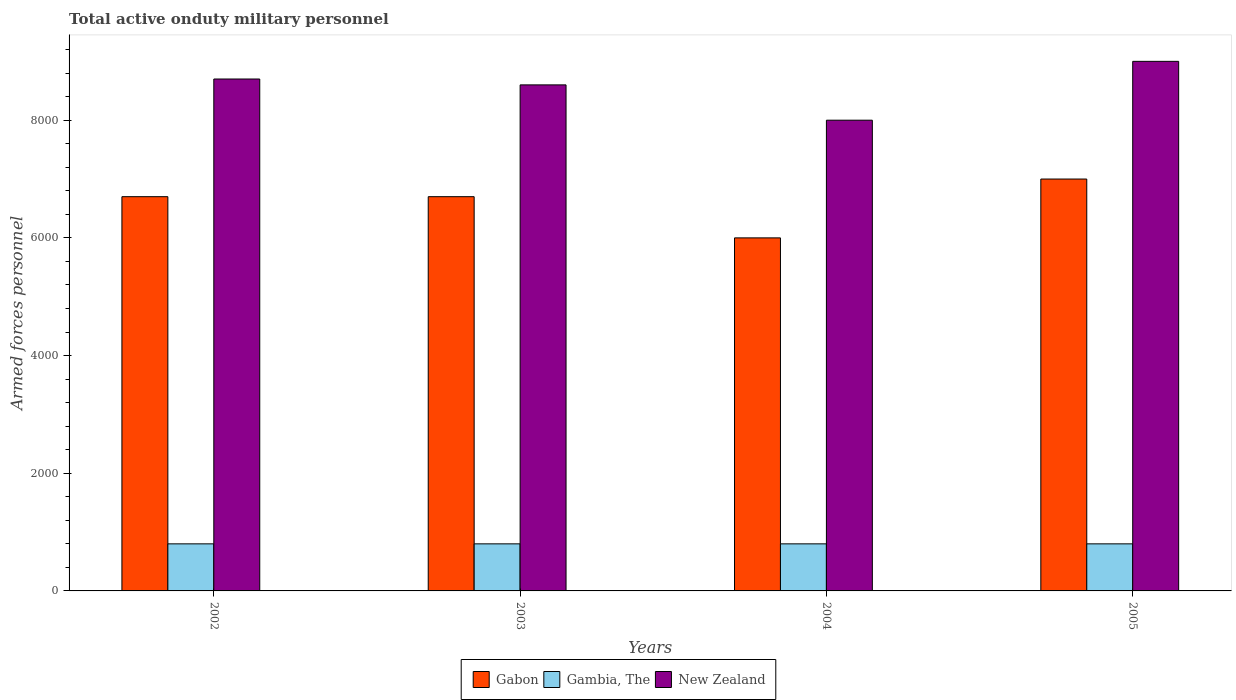How many different coloured bars are there?
Give a very brief answer. 3. How many groups of bars are there?
Provide a succinct answer. 4. Are the number of bars per tick equal to the number of legend labels?
Give a very brief answer. Yes. Are the number of bars on each tick of the X-axis equal?
Offer a very short reply. Yes. How many bars are there on the 2nd tick from the left?
Ensure brevity in your answer.  3. What is the label of the 4th group of bars from the left?
Make the answer very short. 2005. What is the number of armed forces personnel in New Zealand in 2003?
Provide a succinct answer. 8600. Across all years, what is the maximum number of armed forces personnel in Gabon?
Keep it short and to the point. 7000. Across all years, what is the minimum number of armed forces personnel in Gambia, The?
Your response must be concise. 800. In which year was the number of armed forces personnel in Gambia, The maximum?
Offer a terse response. 2002. What is the total number of armed forces personnel in New Zealand in the graph?
Give a very brief answer. 3.43e+04. What is the difference between the number of armed forces personnel in Gambia, The in 2003 and that in 2004?
Your response must be concise. 0. What is the difference between the number of armed forces personnel in New Zealand in 2003 and the number of armed forces personnel in Gambia, The in 2002?
Offer a very short reply. 7800. What is the average number of armed forces personnel in New Zealand per year?
Give a very brief answer. 8575. In the year 2004, what is the difference between the number of armed forces personnel in Gambia, The and number of armed forces personnel in New Zealand?
Provide a succinct answer. -7200. In how many years, is the number of armed forces personnel in Gabon greater than 4800?
Keep it short and to the point. 4. What is the ratio of the number of armed forces personnel in Gabon in 2002 to that in 2004?
Give a very brief answer. 1.12. What is the difference between the highest and the second highest number of armed forces personnel in New Zealand?
Provide a succinct answer. 300. What is the difference between the highest and the lowest number of armed forces personnel in Gambia, The?
Give a very brief answer. 0. In how many years, is the number of armed forces personnel in Gabon greater than the average number of armed forces personnel in Gabon taken over all years?
Your response must be concise. 3. What does the 3rd bar from the left in 2005 represents?
Offer a very short reply. New Zealand. What does the 3rd bar from the right in 2005 represents?
Provide a succinct answer. Gabon. Is it the case that in every year, the sum of the number of armed forces personnel in Gambia, The and number of armed forces personnel in Gabon is greater than the number of armed forces personnel in New Zealand?
Offer a terse response. No. Are all the bars in the graph horizontal?
Give a very brief answer. No. Are the values on the major ticks of Y-axis written in scientific E-notation?
Offer a very short reply. No. How are the legend labels stacked?
Your answer should be very brief. Horizontal. What is the title of the graph?
Give a very brief answer. Total active onduty military personnel. Does "Malaysia" appear as one of the legend labels in the graph?
Offer a terse response. No. What is the label or title of the Y-axis?
Your answer should be compact. Armed forces personnel. What is the Armed forces personnel of Gabon in 2002?
Make the answer very short. 6700. What is the Armed forces personnel of Gambia, The in 2002?
Offer a terse response. 800. What is the Armed forces personnel in New Zealand in 2002?
Your answer should be compact. 8700. What is the Armed forces personnel in Gabon in 2003?
Your response must be concise. 6700. What is the Armed forces personnel in Gambia, The in 2003?
Offer a very short reply. 800. What is the Armed forces personnel in New Zealand in 2003?
Give a very brief answer. 8600. What is the Armed forces personnel in Gabon in 2004?
Your answer should be very brief. 6000. What is the Armed forces personnel in Gambia, The in 2004?
Give a very brief answer. 800. What is the Armed forces personnel of New Zealand in 2004?
Your response must be concise. 8000. What is the Armed forces personnel of Gabon in 2005?
Offer a terse response. 7000. What is the Armed forces personnel in Gambia, The in 2005?
Ensure brevity in your answer.  800. What is the Armed forces personnel in New Zealand in 2005?
Provide a short and direct response. 9000. Across all years, what is the maximum Armed forces personnel of Gabon?
Offer a very short reply. 7000. Across all years, what is the maximum Armed forces personnel of Gambia, The?
Give a very brief answer. 800. Across all years, what is the maximum Armed forces personnel in New Zealand?
Your answer should be very brief. 9000. Across all years, what is the minimum Armed forces personnel of Gabon?
Your answer should be very brief. 6000. Across all years, what is the minimum Armed forces personnel of Gambia, The?
Offer a terse response. 800. Across all years, what is the minimum Armed forces personnel in New Zealand?
Your response must be concise. 8000. What is the total Armed forces personnel in Gabon in the graph?
Your answer should be compact. 2.64e+04. What is the total Armed forces personnel in Gambia, The in the graph?
Provide a short and direct response. 3200. What is the total Armed forces personnel in New Zealand in the graph?
Provide a short and direct response. 3.43e+04. What is the difference between the Armed forces personnel of Gabon in 2002 and that in 2003?
Your answer should be compact. 0. What is the difference between the Armed forces personnel in Gabon in 2002 and that in 2004?
Offer a very short reply. 700. What is the difference between the Armed forces personnel of New Zealand in 2002 and that in 2004?
Keep it short and to the point. 700. What is the difference between the Armed forces personnel in Gabon in 2002 and that in 2005?
Make the answer very short. -300. What is the difference between the Armed forces personnel in Gambia, The in 2002 and that in 2005?
Your answer should be compact. 0. What is the difference between the Armed forces personnel of New Zealand in 2002 and that in 2005?
Provide a succinct answer. -300. What is the difference between the Armed forces personnel in Gabon in 2003 and that in 2004?
Your response must be concise. 700. What is the difference between the Armed forces personnel in Gambia, The in 2003 and that in 2004?
Your answer should be very brief. 0. What is the difference between the Armed forces personnel in New Zealand in 2003 and that in 2004?
Offer a very short reply. 600. What is the difference between the Armed forces personnel of Gabon in 2003 and that in 2005?
Ensure brevity in your answer.  -300. What is the difference between the Armed forces personnel in Gambia, The in 2003 and that in 2005?
Provide a succinct answer. 0. What is the difference between the Armed forces personnel in New Zealand in 2003 and that in 2005?
Offer a terse response. -400. What is the difference between the Armed forces personnel in Gabon in 2004 and that in 2005?
Offer a terse response. -1000. What is the difference between the Armed forces personnel in Gambia, The in 2004 and that in 2005?
Your answer should be compact. 0. What is the difference between the Armed forces personnel of New Zealand in 2004 and that in 2005?
Your response must be concise. -1000. What is the difference between the Armed forces personnel in Gabon in 2002 and the Armed forces personnel in Gambia, The in 2003?
Your response must be concise. 5900. What is the difference between the Armed forces personnel in Gabon in 2002 and the Armed forces personnel in New Zealand in 2003?
Your answer should be compact. -1900. What is the difference between the Armed forces personnel of Gambia, The in 2002 and the Armed forces personnel of New Zealand in 2003?
Your response must be concise. -7800. What is the difference between the Armed forces personnel of Gabon in 2002 and the Armed forces personnel of Gambia, The in 2004?
Make the answer very short. 5900. What is the difference between the Armed forces personnel in Gabon in 2002 and the Armed forces personnel in New Zealand in 2004?
Give a very brief answer. -1300. What is the difference between the Armed forces personnel of Gambia, The in 2002 and the Armed forces personnel of New Zealand in 2004?
Provide a succinct answer. -7200. What is the difference between the Armed forces personnel of Gabon in 2002 and the Armed forces personnel of Gambia, The in 2005?
Provide a short and direct response. 5900. What is the difference between the Armed forces personnel in Gabon in 2002 and the Armed forces personnel in New Zealand in 2005?
Your answer should be very brief. -2300. What is the difference between the Armed forces personnel in Gambia, The in 2002 and the Armed forces personnel in New Zealand in 2005?
Your answer should be compact. -8200. What is the difference between the Armed forces personnel in Gabon in 2003 and the Armed forces personnel in Gambia, The in 2004?
Your response must be concise. 5900. What is the difference between the Armed forces personnel in Gabon in 2003 and the Armed forces personnel in New Zealand in 2004?
Your answer should be compact. -1300. What is the difference between the Armed forces personnel in Gambia, The in 2003 and the Armed forces personnel in New Zealand in 2004?
Your answer should be compact. -7200. What is the difference between the Armed forces personnel in Gabon in 2003 and the Armed forces personnel in Gambia, The in 2005?
Provide a short and direct response. 5900. What is the difference between the Armed forces personnel of Gabon in 2003 and the Armed forces personnel of New Zealand in 2005?
Provide a succinct answer. -2300. What is the difference between the Armed forces personnel in Gambia, The in 2003 and the Armed forces personnel in New Zealand in 2005?
Your answer should be very brief. -8200. What is the difference between the Armed forces personnel in Gabon in 2004 and the Armed forces personnel in Gambia, The in 2005?
Give a very brief answer. 5200. What is the difference between the Armed forces personnel of Gabon in 2004 and the Armed forces personnel of New Zealand in 2005?
Give a very brief answer. -3000. What is the difference between the Armed forces personnel in Gambia, The in 2004 and the Armed forces personnel in New Zealand in 2005?
Ensure brevity in your answer.  -8200. What is the average Armed forces personnel of Gabon per year?
Ensure brevity in your answer.  6600. What is the average Armed forces personnel in Gambia, The per year?
Provide a succinct answer. 800. What is the average Armed forces personnel of New Zealand per year?
Give a very brief answer. 8575. In the year 2002, what is the difference between the Armed forces personnel in Gabon and Armed forces personnel in Gambia, The?
Your response must be concise. 5900. In the year 2002, what is the difference between the Armed forces personnel of Gabon and Armed forces personnel of New Zealand?
Offer a terse response. -2000. In the year 2002, what is the difference between the Armed forces personnel in Gambia, The and Armed forces personnel in New Zealand?
Your response must be concise. -7900. In the year 2003, what is the difference between the Armed forces personnel in Gabon and Armed forces personnel in Gambia, The?
Provide a short and direct response. 5900. In the year 2003, what is the difference between the Armed forces personnel of Gabon and Armed forces personnel of New Zealand?
Keep it short and to the point. -1900. In the year 2003, what is the difference between the Armed forces personnel in Gambia, The and Armed forces personnel in New Zealand?
Offer a terse response. -7800. In the year 2004, what is the difference between the Armed forces personnel in Gabon and Armed forces personnel in Gambia, The?
Provide a succinct answer. 5200. In the year 2004, what is the difference between the Armed forces personnel in Gabon and Armed forces personnel in New Zealand?
Provide a succinct answer. -2000. In the year 2004, what is the difference between the Armed forces personnel in Gambia, The and Armed forces personnel in New Zealand?
Offer a very short reply. -7200. In the year 2005, what is the difference between the Armed forces personnel in Gabon and Armed forces personnel in Gambia, The?
Keep it short and to the point. 6200. In the year 2005, what is the difference between the Armed forces personnel of Gabon and Armed forces personnel of New Zealand?
Your answer should be compact. -2000. In the year 2005, what is the difference between the Armed forces personnel of Gambia, The and Armed forces personnel of New Zealand?
Offer a very short reply. -8200. What is the ratio of the Armed forces personnel of Gabon in 2002 to that in 2003?
Offer a very short reply. 1. What is the ratio of the Armed forces personnel of New Zealand in 2002 to that in 2003?
Give a very brief answer. 1.01. What is the ratio of the Armed forces personnel in Gabon in 2002 to that in 2004?
Offer a very short reply. 1.12. What is the ratio of the Armed forces personnel in New Zealand in 2002 to that in 2004?
Keep it short and to the point. 1.09. What is the ratio of the Armed forces personnel in Gabon in 2002 to that in 2005?
Offer a very short reply. 0.96. What is the ratio of the Armed forces personnel in Gambia, The in 2002 to that in 2005?
Give a very brief answer. 1. What is the ratio of the Armed forces personnel in New Zealand in 2002 to that in 2005?
Offer a very short reply. 0.97. What is the ratio of the Armed forces personnel in Gabon in 2003 to that in 2004?
Your answer should be very brief. 1.12. What is the ratio of the Armed forces personnel of Gambia, The in 2003 to that in 2004?
Offer a terse response. 1. What is the ratio of the Armed forces personnel of New Zealand in 2003 to that in 2004?
Keep it short and to the point. 1.07. What is the ratio of the Armed forces personnel in Gabon in 2003 to that in 2005?
Offer a very short reply. 0.96. What is the ratio of the Armed forces personnel of New Zealand in 2003 to that in 2005?
Make the answer very short. 0.96. What is the difference between the highest and the second highest Armed forces personnel in Gabon?
Keep it short and to the point. 300. What is the difference between the highest and the second highest Armed forces personnel of Gambia, The?
Ensure brevity in your answer.  0. What is the difference between the highest and the second highest Armed forces personnel of New Zealand?
Provide a succinct answer. 300. What is the difference between the highest and the lowest Armed forces personnel of Gambia, The?
Your response must be concise. 0. What is the difference between the highest and the lowest Armed forces personnel in New Zealand?
Offer a very short reply. 1000. 